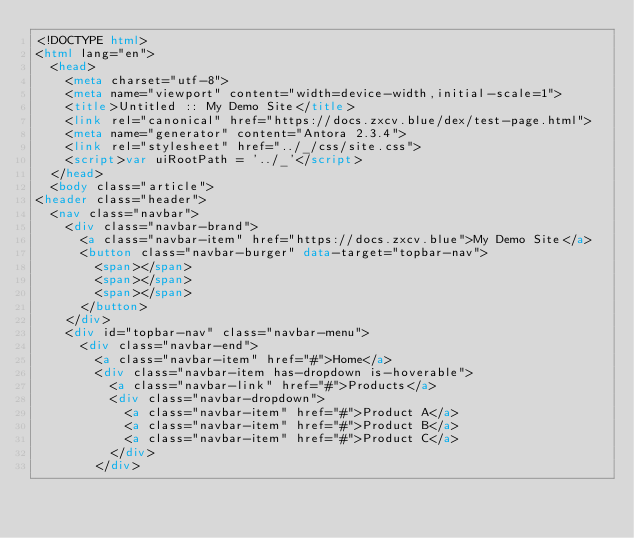Convert code to text. <code><loc_0><loc_0><loc_500><loc_500><_HTML_><!DOCTYPE html>
<html lang="en">
  <head>
    <meta charset="utf-8">
    <meta name="viewport" content="width=device-width,initial-scale=1">
    <title>Untitled :: My Demo Site</title>
    <link rel="canonical" href="https://docs.zxcv.blue/dex/test-page.html">
    <meta name="generator" content="Antora 2.3.4">
    <link rel="stylesheet" href="../_/css/site.css">
    <script>var uiRootPath = '../_'</script>
  </head>
  <body class="article">
<header class="header">
  <nav class="navbar">
    <div class="navbar-brand">
      <a class="navbar-item" href="https://docs.zxcv.blue">My Demo Site</a>
      <button class="navbar-burger" data-target="topbar-nav">
        <span></span>
        <span></span>
        <span></span>
      </button>
    </div>
    <div id="topbar-nav" class="navbar-menu">
      <div class="navbar-end">
        <a class="navbar-item" href="#">Home</a>
        <div class="navbar-item has-dropdown is-hoverable">
          <a class="navbar-link" href="#">Products</a>
          <div class="navbar-dropdown">
            <a class="navbar-item" href="#">Product A</a>
            <a class="navbar-item" href="#">Product B</a>
            <a class="navbar-item" href="#">Product C</a>
          </div>
        </div></code> 